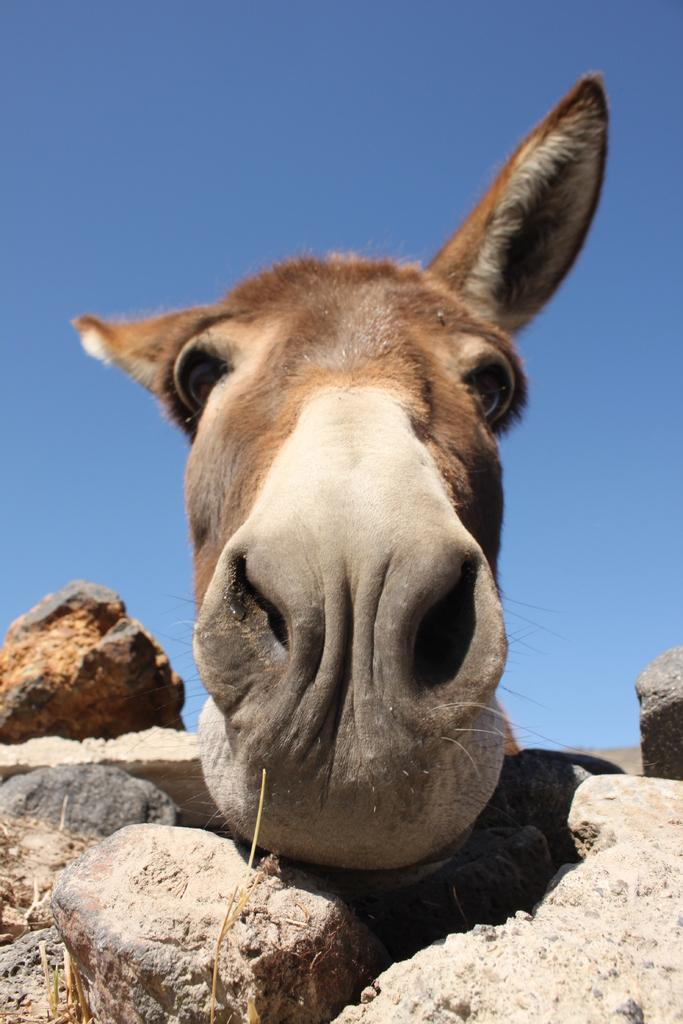What is depicted on the wall in the image? There is a donkey face on the wall in the image. What material is the wall made of? The wall is made of stones. What type of lock is used to secure the donkey face on the wall? There is no lock present in the image, as the donkey face is a painting or mural on the wall. What is the texture of the donkey face in the image? The texture of the donkey face cannot be determined from the image, as it is a two-dimensional representation. 